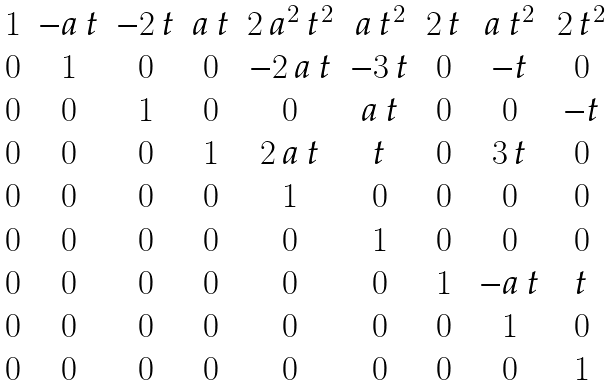Convert formula to latex. <formula><loc_0><loc_0><loc_500><loc_500>\begin{matrix} 1 & - a \, t & - 2 \, t & a \, t & 2 \, a ^ { 2 } \, t ^ { 2 } & a \, t ^ { 2 } & 2 \, t & a \, t ^ { 2 } & 2 \, t ^ { 2 } \\ 0 & 1 & 0 & 0 & - 2 \, a \, t & - 3 \, t & 0 & - t & 0 \\ 0 & 0 & 1 & 0 & 0 & a \, t & 0 & 0 & - t \\ 0 & 0 & 0 & 1 & 2 \, a \, t & t & 0 & 3 \, t & 0 \\ 0 & 0 & 0 & 0 & 1 & 0 & 0 & 0 & 0 \\ 0 & 0 & 0 & 0 & 0 & 1 & 0 & 0 & 0 \\ 0 & 0 & 0 & 0 & 0 & 0 & 1 & - a \, t & t \\ 0 & 0 & 0 & 0 & 0 & 0 & 0 & 1 & 0 \\ 0 & 0 & 0 & 0 & 0 & 0 & 0 & 0 & 1 \end{matrix}</formula> 